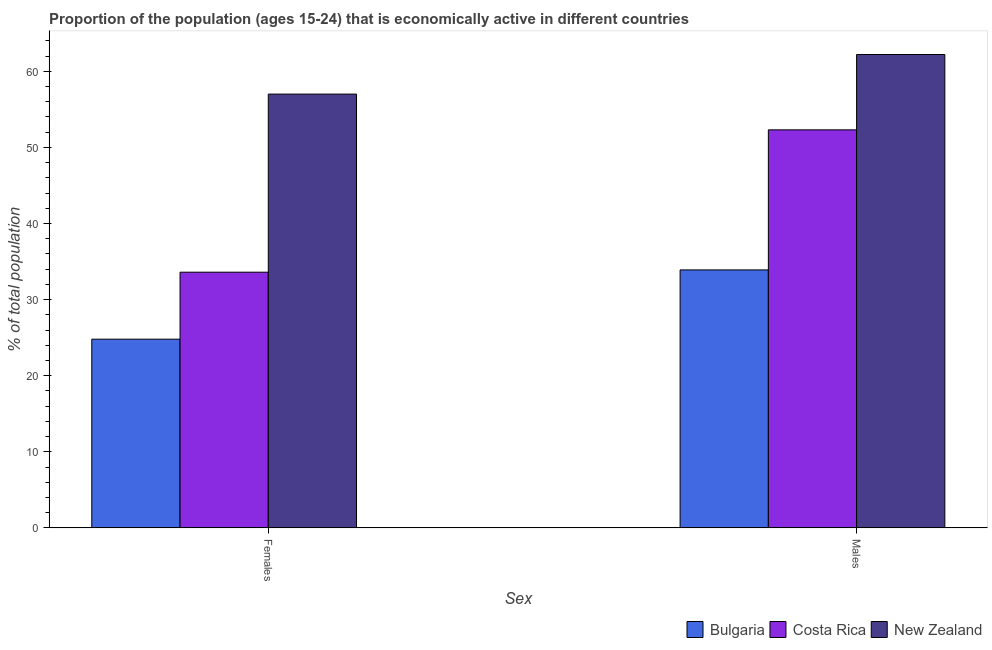How many different coloured bars are there?
Make the answer very short. 3. What is the label of the 1st group of bars from the left?
Provide a succinct answer. Females. What is the percentage of economically active female population in Costa Rica?
Your answer should be very brief. 33.6. Across all countries, what is the maximum percentage of economically active male population?
Offer a very short reply. 62.2. Across all countries, what is the minimum percentage of economically active female population?
Keep it short and to the point. 24.8. In which country was the percentage of economically active female population maximum?
Offer a very short reply. New Zealand. What is the total percentage of economically active female population in the graph?
Provide a short and direct response. 115.4. What is the difference between the percentage of economically active male population in New Zealand and that in Costa Rica?
Your answer should be compact. 9.9. What is the difference between the percentage of economically active female population in Bulgaria and the percentage of economically active male population in New Zealand?
Make the answer very short. -37.4. What is the average percentage of economically active male population per country?
Your answer should be very brief. 49.47. What is the difference between the percentage of economically active female population and percentage of economically active male population in New Zealand?
Your response must be concise. -5.2. What is the ratio of the percentage of economically active female population in Costa Rica to that in Bulgaria?
Keep it short and to the point. 1.35. Is the percentage of economically active female population in Bulgaria less than that in Costa Rica?
Give a very brief answer. Yes. What does the 2nd bar from the left in Females represents?
Ensure brevity in your answer.  Costa Rica. What does the 3rd bar from the right in Females represents?
Offer a terse response. Bulgaria. Are all the bars in the graph horizontal?
Your response must be concise. No. Are the values on the major ticks of Y-axis written in scientific E-notation?
Provide a short and direct response. No. How many legend labels are there?
Keep it short and to the point. 3. What is the title of the graph?
Offer a very short reply. Proportion of the population (ages 15-24) that is economically active in different countries. Does "Qatar" appear as one of the legend labels in the graph?
Offer a terse response. No. What is the label or title of the X-axis?
Give a very brief answer. Sex. What is the label or title of the Y-axis?
Ensure brevity in your answer.  % of total population. What is the % of total population of Bulgaria in Females?
Offer a very short reply. 24.8. What is the % of total population of Costa Rica in Females?
Your response must be concise. 33.6. What is the % of total population of New Zealand in Females?
Keep it short and to the point. 57. What is the % of total population in Bulgaria in Males?
Make the answer very short. 33.9. What is the % of total population of Costa Rica in Males?
Offer a very short reply. 52.3. What is the % of total population of New Zealand in Males?
Your response must be concise. 62.2. Across all Sex, what is the maximum % of total population of Bulgaria?
Provide a succinct answer. 33.9. Across all Sex, what is the maximum % of total population in Costa Rica?
Provide a succinct answer. 52.3. Across all Sex, what is the maximum % of total population of New Zealand?
Keep it short and to the point. 62.2. Across all Sex, what is the minimum % of total population of Bulgaria?
Make the answer very short. 24.8. Across all Sex, what is the minimum % of total population of Costa Rica?
Provide a succinct answer. 33.6. Across all Sex, what is the minimum % of total population of New Zealand?
Give a very brief answer. 57. What is the total % of total population in Bulgaria in the graph?
Provide a short and direct response. 58.7. What is the total % of total population of Costa Rica in the graph?
Offer a very short reply. 85.9. What is the total % of total population of New Zealand in the graph?
Provide a succinct answer. 119.2. What is the difference between the % of total population in Bulgaria in Females and that in Males?
Your response must be concise. -9.1. What is the difference between the % of total population of Costa Rica in Females and that in Males?
Provide a short and direct response. -18.7. What is the difference between the % of total population of Bulgaria in Females and the % of total population of Costa Rica in Males?
Keep it short and to the point. -27.5. What is the difference between the % of total population of Bulgaria in Females and the % of total population of New Zealand in Males?
Ensure brevity in your answer.  -37.4. What is the difference between the % of total population of Costa Rica in Females and the % of total population of New Zealand in Males?
Make the answer very short. -28.6. What is the average % of total population in Bulgaria per Sex?
Your answer should be very brief. 29.35. What is the average % of total population in Costa Rica per Sex?
Ensure brevity in your answer.  42.95. What is the average % of total population of New Zealand per Sex?
Provide a short and direct response. 59.6. What is the difference between the % of total population of Bulgaria and % of total population of Costa Rica in Females?
Your answer should be compact. -8.8. What is the difference between the % of total population in Bulgaria and % of total population in New Zealand in Females?
Your response must be concise. -32.2. What is the difference between the % of total population of Costa Rica and % of total population of New Zealand in Females?
Offer a very short reply. -23.4. What is the difference between the % of total population in Bulgaria and % of total population in Costa Rica in Males?
Provide a succinct answer. -18.4. What is the difference between the % of total population in Bulgaria and % of total population in New Zealand in Males?
Provide a short and direct response. -28.3. What is the ratio of the % of total population of Bulgaria in Females to that in Males?
Your answer should be compact. 0.73. What is the ratio of the % of total population in Costa Rica in Females to that in Males?
Provide a short and direct response. 0.64. What is the ratio of the % of total population of New Zealand in Females to that in Males?
Keep it short and to the point. 0.92. What is the difference between the highest and the lowest % of total population of Costa Rica?
Your response must be concise. 18.7. 